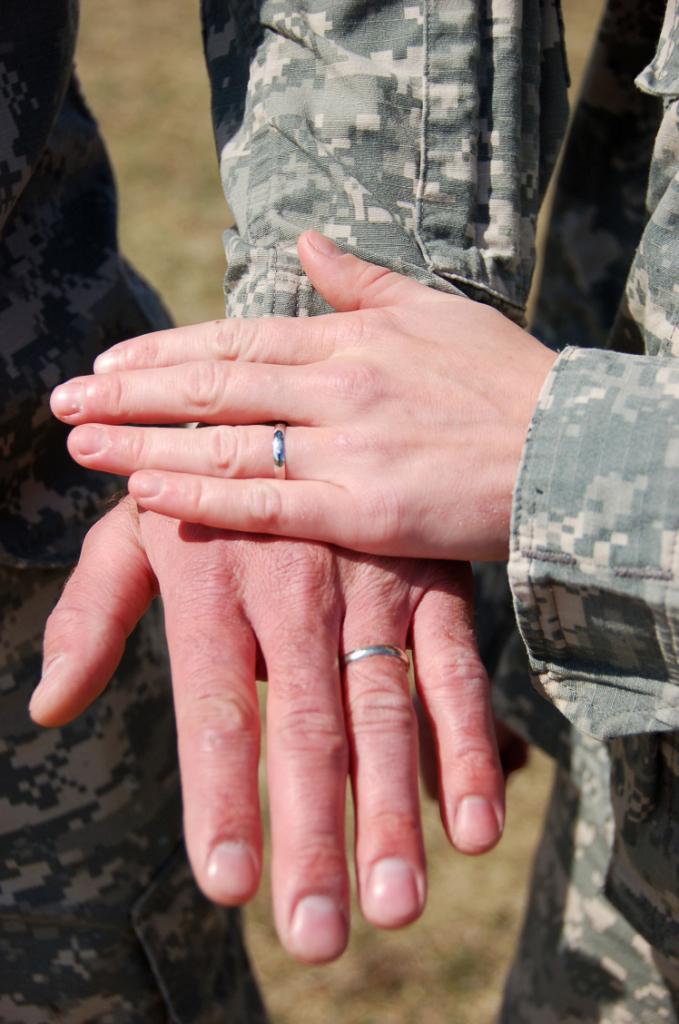Can you describe this image briefly? In the center of the image we can see persons hand and hand rings are present. At the bottom of the image ground is there. 